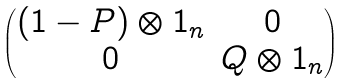<formula> <loc_0><loc_0><loc_500><loc_500>\begin{pmatrix} ( 1 - P ) \otimes 1 _ { n } & 0 \\ 0 & Q \otimes 1 _ { n } \end{pmatrix}</formula> 